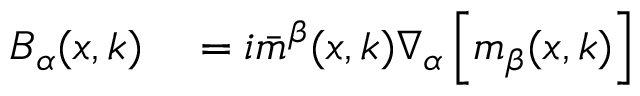<formula> <loc_0><loc_0><loc_500><loc_500>\begin{array} { r l } { B _ { \alpha } ( x , k ) } & = i \bar { m } ^ { \beta } ( x , k ) \nabla _ { \alpha } \left [ m _ { \beta } ( x , k ) \right ] } \end{array}</formula> 